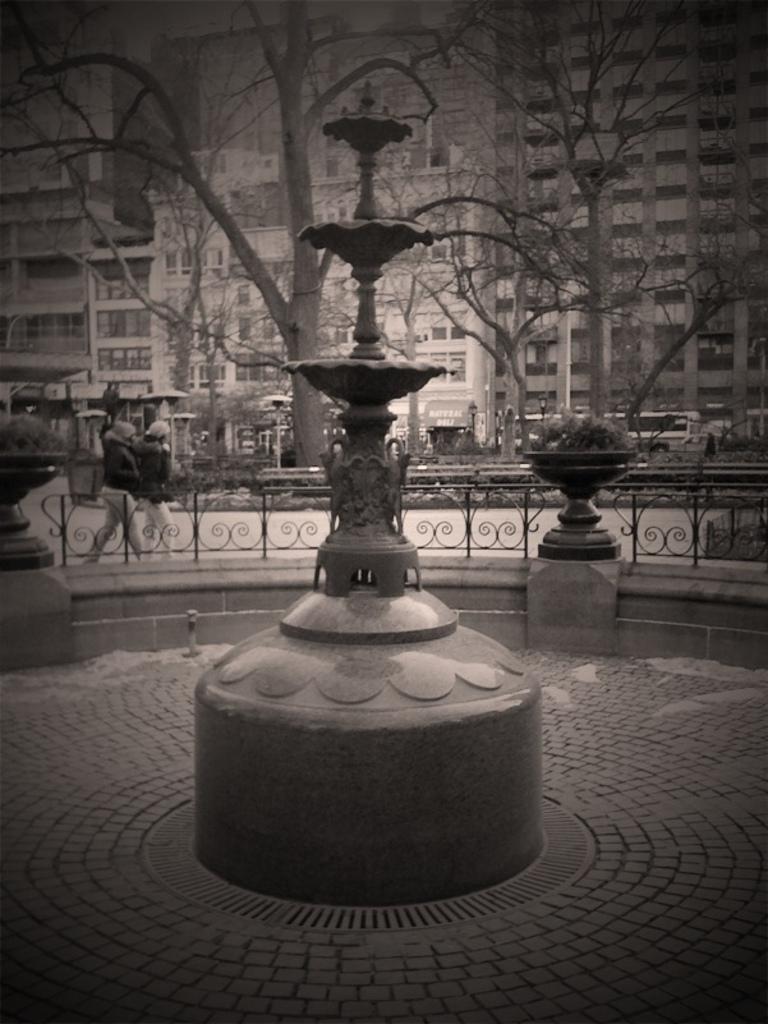Can you describe this image briefly? In this image I can see a fountain in the front. In the background I can see few plants, railing, few trees and few buildings. On the left side of this image I can see two persons are standing. I can also see this image is black and white in colour. 